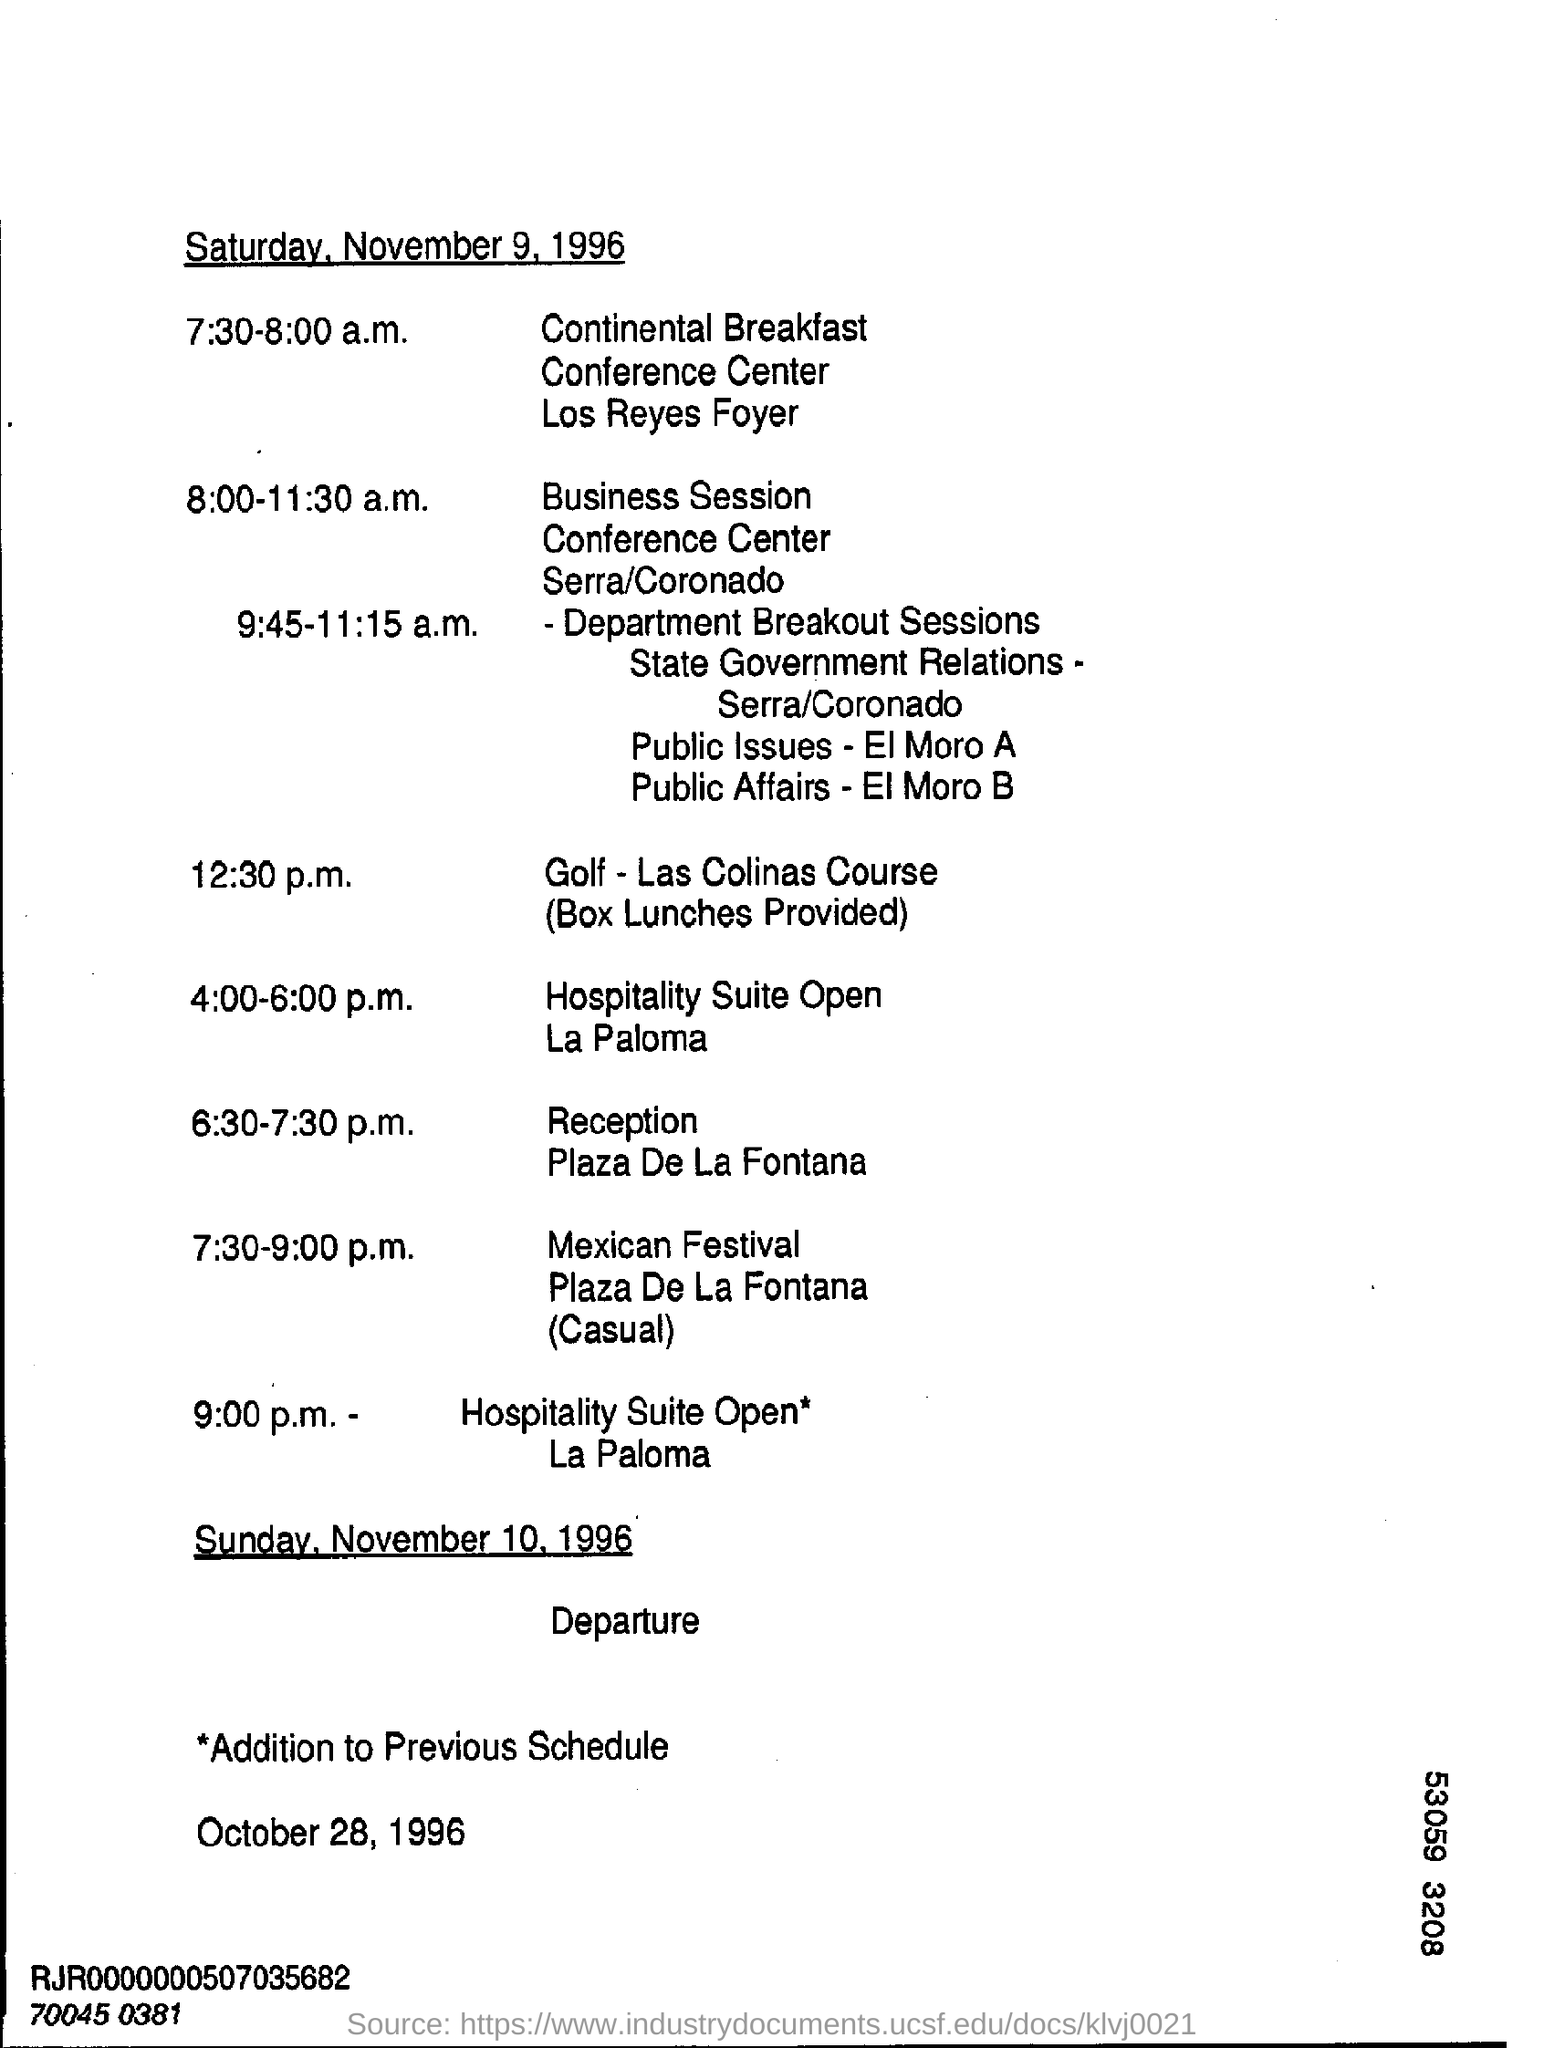Mention a couple of crucial points in this snapshot. The Reception will take place between 6:30 and 7:30 p.m. On November 10, 1996, the departure date is. At 12:30 p.m., the event is golf. 